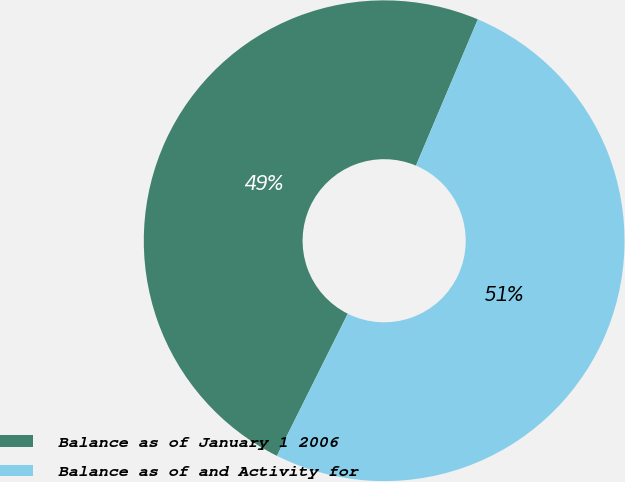Convert chart to OTSL. <chart><loc_0><loc_0><loc_500><loc_500><pie_chart><fcel>Balance as of January 1 2006<fcel>Balance as of and Activity for<nl><fcel>49.01%<fcel>50.99%<nl></chart> 